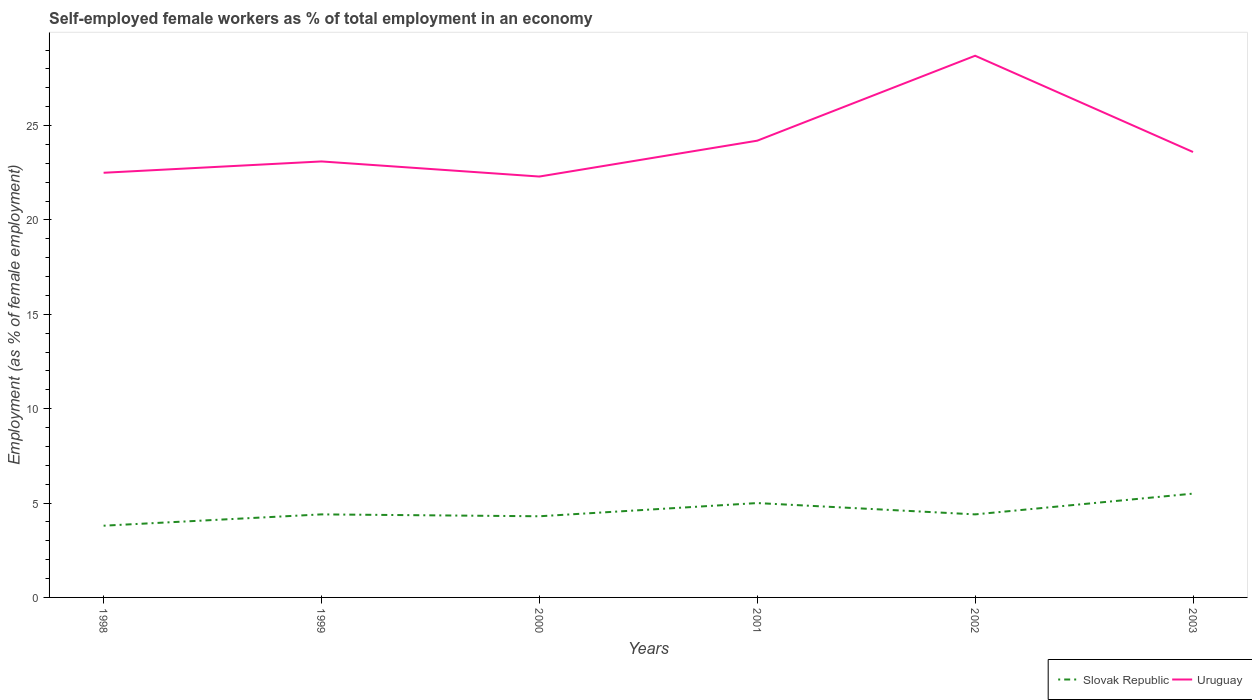How many different coloured lines are there?
Offer a very short reply. 2. Does the line corresponding to Slovak Republic intersect with the line corresponding to Uruguay?
Your answer should be compact. No. Is the number of lines equal to the number of legend labels?
Offer a terse response. Yes. Across all years, what is the maximum percentage of self-employed female workers in Uruguay?
Offer a terse response. 22.3. In which year was the percentage of self-employed female workers in Uruguay maximum?
Offer a very short reply. 2000. What is the total percentage of self-employed female workers in Uruguay in the graph?
Provide a succinct answer. -0.5. What is the difference between the highest and the second highest percentage of self-employed female workers in Uruguay?
Provide a short and direct response. 6.4. What is the difference between the highest and the lowest percentage of self-employed female workers in Slovak Republic?
Make the answer very short. 2. Is the percentage of self-employed female workers in Slovak Republic strictly greater than the percentage of self-employed female workers in Uruguay over the years?
Offer a very short reply. Yes. How many lines are there?
Give a very brief answer. 2. How many years are there in the graph?
Your answer should be compact. 6. What is the difference between two consecutive major ticks on the Y-axis?
Your response must be concise. 5. Are the values on the major ticks of Y-axis written in scientific E-notation?
Make the answer very short. No. Does the graph contain any zero values?
Keep it short and to the point. No. How many legend labels are there?
Your answer should be compact. 2. How are the legend labels stacked?
Your answer should be compact. Horizontal. What is the title of the graph?
Keep it short and to the point. Self-employed female workers as % of total employment in an economy. What is the label or title of the X-axis?
Give a very brief answer. Years. What is the label or title of the Y-axis?
Offer a terse response. Employment (as % of female employment). What is the Employment (as % of female employment) in Slovak Republic in 1998?
Your answer should be compact. 3.8. What is the Employment (as % of female employment) in Uruguay in 1998?
Your answer should be very brief. 22.5. What is the Employment (as % of female employment) of Slovak Republic in 1999?
Your answer should be very brief. 4.4. What is the Employment (as % of female employment) in Uruguay in 1999?
Your answer should be very brief. 23.1. What is the Employment (as % of female employment) of Slovak Republic in 2000?
Provide a short and direct response. 4.3. What is the Employment (as % of female employment) of Uruguay in 2000?
Offer a terse response. 22.3. What is the Employment (as % of female employment) in Uruguay in 2001?
Make the answer very short. 24.2. What is the Employment (as % of female employment) in Slovak Republic in 2002?
Provide a succinct answer. 4.4. What is the Employment (as % of female employment) of Uruguay in 2002?
Offer a very short reply. 28.7. What is the Employment (as % of female employment) in Slovak Republic in 2003?
Give a very brief answer. 5.5. What is the Employment (as % of female employment) in Uruguay in 2003?
Keep it short and to the point. 23.6. Across all years, what is the maximum Employment (as % of female employment) in Uruguay?
Offer a terse response. 28.7. Across all years, what is the minimum Employment (as % of female employment) of Slovak Republic?
Your answer should be very brief. 3.8. Across all years, what is the minimum Employment (as % of female employment) of Uruguay?
Your answer should be compact. 22.3. What is the total Employment (as % of female employment) of Slovak Republic in the graph?
Offer a very short reply. 27.4. What is the total Employment (as % of female employment) of Uruguay in the graph?
Your answer should be very brief. 144.4. What is the difference between the Employment (as % of female employment) in Slovak Republic in 1998 and that in 1999?
Your response must be concise. -0.6. What is the difference between the Employment (as % of female employment) of Uruguay in 1998 and that in 2000?
Keep it short and to the point. 0.2. What is the difference between the Employment (as % of female employment) in Slovak Republic in 1998 and that in 2001?
Your response must be concise. -1.2. What is the difference between the Employment (as % of female employment) in Uruguay in 1998 and that in 2001?
Ensure brevity in your answer.  -1.7. What is the difference between the Employment (as % of female employment) in Slovak Republic in 1998 and that in 2002?
Keep it short and to the point. -0.6. What is the difference between the Employment (as % of female employment) of Slovak Republic in 1999 and that in 2000?
Keep it short and to the point. 0.1. What is the difference between the Employment (as % of female employment) in Uruguay in 1999 and that in 2000?
Your response must be concise. 0.8. What is the difference between the Employment (as % of female employment) in Slovak Republic in 1999 and that in 2001?
Provide a short and direct response. -0.6. What is the difference between the Employment (as % of female employment) of Uruguay in 1999 and that in 2001?
Your answer should be very brief. -1.1. What is the difference between the Employment (as % of female employment) of Uruguay in 2000 and that in 2001?
Offer a terse response. -1.9. What is the difference between the Employment (as % of female employment) of Uruguay in 2000 and that in 2003?
Make the answer very short. -1.3. What is the difference between the Employment (as % of female employment) in Uruguay in 2001 and that in 2002?
Your answer should be compact. -4.5. What is the difference between the Employment (as % of female employment) in Slovak Republic in 2002 and that in 2003?
Make the answer very short. -1.1. What is the difference between the Employment (as % of female employment) in Slovak Republic in 1998 and the Employment (as % of female employment) in Uruguay in 1999?
Provide a short and direct response. -19.3. What is the difference between the Employment (as % of female employment) in Slovak Republic in 1998 and the Employment (as % of female employment) in Uruguay in 2000?
Make the answer very short. -18.5. What is the difference between the Employment (as % of female employment) in Slovak Republic in 1998 and the Employment (as % of female employment) in Uruguay in 2001?
Your response must be concise. -20.4. What is the difference between the Employment (as % of female employment) in Slovak Republic in 1998 and the Employment (as % of female employment) in Uruguay in 2002?
Offer a terse response. -24.9. What is the difference between the Employment (as % of female employment) in Slovak Republic in 1998 and the Employment (as % of female employment) in Uruguay in 2003?
Make the answer very short. -19.8. What is the difference between the Employment (as % of female employment) in Slovak Republic in 1999 and the Employment (as % of female employment) in Uruguay in 2000?
Ensure brevity in your answer.  -17.9. What is the difference between the Employment (as % of female employment) in Slovak Republic in 1999 and the Employment (as % of female employment) in Uruguay in 2001?
Ensure brevity in your answer.  -19.8. What is the difference between the Employment (as % of female employment) in Slovak Republic in 1999 and the Employment (as % of female employment) in Uruguay in 2002?
Your answer should be very brief. -24.3. What is the difference between the Employment (as % of female employment) in Slovak Republic in 1999 and the Employment (as % of female employment) in Uruguay in 2003?
Give a very brief answer. -19.2. What is the difference between the Employment (as % of female employment) in Slovak Republic in 2000 and the Employment (as % of female employment) in Uruguay in 2001?
Give a very brief answer. -19.9. What is the difference between the Employment (as % of female employment) in Slovak Republic in 2000 and the Employment (as % of female employment) in Uruguay in 2002?
Give a very brief answer. -24.4. What is the difference between the Employment (as % of female employment) in Slovak Republic in 2000 and the Employment (as % of female employment) in Uruguay in 2003?
Ensure brevity in your answer.  -19.3. What is the difference between the Employment (as % of female employment) in Slovak Republic in 2001 and the Employment (as % of female employment) in Uruguay in 2002?
Your answer should be compact. -23.7. What is the difference between the Employment (as % of female employment) in Slovak Republic in 2001 and the Employment (as % of female employment) in Uruguay in 2003?
Your answer should be very brief. -18.6. What is the difference between the Employment (as % of female employment) of Slovak Republic in 2002 and the Employment (as % of female employment) of Uruguay in 2003?
Offer a terse response. -19.2. What is the average Employment (as % of female employment) in Slovak Republic per year?
Your response must be concise. 4.57. What is the average Employment (as % of female employment) in Uruguay per year?
Your answer should be very brief. 24.07. In the year 1998, what is the difference between the Employment (as % of female employment) in Slovak Republic and Employment (as % of female employment) in Uruguay?
Keep it short and to the point. -18.7. In the year 1999, what is the difference between the Employment (as % of female employment) of Slovak Republic and Employment (as % of female employment) of Uruguay?
Your answer should be compact. -18.7. In the year 2001, what is the difference between the Employment (as % of female employment) in Slovak Republic and Employment (as % of female employment) in Uruguay?
Offer a terse response. -19.2. In the year 2002, what is the difference between the Employment (as % of female employment) of Slovak Republic and Employment (as % of female employment) of Uruguay?
Provide a short and direct response. -24.3. In the year 2003, what is the difference between the Employment (as % of female employment) in Slovak Republic and Employment (as % of female employment) in Uruguay?
Your answer should be compact. -18.1. What is the ratio of the Employment (as % of female employment) of Slovak Republic in 1998 to that in 1999?
Your response must be concise. 0.86. What is the ratio of the Employment (as % of female employment) in Slovak Republic in 1998 to that in 2000?
Ensure brevity in your answer.  0.88. What is the ratio of the Employment (as % of female employment) of Slovak Republic in 1998 to that in 2001?
Your answer should be very brief. 0.76. What is the ratio of the Employment (as % of female employment) in Uruguay in 1998 to that in 2001?
Keep it short and to the point. 0.93. What is the ratio of the Employment (as % of female employment) in Slovak Republic in 1998 to that in 2002?
Offer a terse response. 0.86. What is the ratio of the Employment (as % of female employment) in Uruguay in 1998 to that in 2002?
Provide a succinct answer. 0.78. What is the ratio of the Employment (as % of female employment) of Slovak Republic in 1998 to that in 2003?
Ensure brevity in your answer.  0.69. What is the ratio of the Employment (as % of female employment) of Uruguay in 1998 to that in 2003?
Make the answer very short. 0.95. What is the ratio of the Employment (as % of female employment) of Slovak Republic in 1999 to that in 2000?
Give a very brief answer. 1.02. What is the ratio of the Employment (as % of female employment) in Uruguay in 1999 to that in 2000?
Your answer should be compact. 1.04. What is the ratio of the Employment (as % of female employment) of Slovak Republic in 1999 to that in 2001?
Give a very brief answer. 0.88. What is the ratio of the Employment (as % of female employment) of Uruguay in 1999 to that in 2001?
Your response must be concise. 0.95. What is the ratio of the Employment (as % of female employment) of Slovak Republic in 1999 to that in 2002?
Offer a very short reply. 1. What is the ratio of the Employment (as % of female employment) in Uruguay in 1999 to that in 2002?
Provide a succinct answer. 0.8. What is the ratio of the Employment (as % of female employment) of Slovak Republic in 1999 to that in 2003?
Make the answer very short. 0.8. What is the ratio of the Employment (as % of female employment) in Uruguay in 1999 to that in 2003?
Provide a succinct answer. 0.98. What is the ratio of the Employment (as % of female employment) in Slovak Republic in 2000 to that in 2001?
Offer a very short reply. 0.86. What is the ratio of the Employment (as % of female employment) in Uruguay in 2000 to that in 2001?
Ensure brevity in your answer.  0.92. What is the ratio of the Employment (as % of female employment) of Slovak Republic in 2000 to that in 2002?
Your response must be concise. 0.98. What is the ratio of the Employment (as % of female employment) in Uruguay in 2000 to that in 2002?
Your answer should be compact. 0.78. What is the ratio of the Employment (as % of female employment) in Slovak Republic in 2000 to that in 2003?
Give a very brief answer. 0.78. What is the ratio of the Employment (as % of female employment) in Uruguay in 2000 to that in 2003?
Ensure brevity in your answer.  0.94. What is the ratio of the Employment (as % of female employment) in Slovak Republic in 2001 to that in 2002?
Provide a succinct answer. 1.14. What is the ratio of the Employment (as % of female employment) in Uruguay in 2001 to that in 2002?
Give a very brief answer. 0.84. What is the ratio of the Employment (as % of female employment) in Slovak Republic in 2001 to that in 2003?
Your response must be concise. 0.91. What is the ratio of the Employment (as % of female employment) of Uruguay in 2001 to that in 2003?
Your answer should be very brief. 1.03. What is the ratio of the Employment (as % of female employment) in Slovak Republic in 2002 to that in 2003?
Provide a succinct answer. 0.8. What is the ratio of the Employment (as % of female employment) in Uruguay in 2002 to that in 2003?
Offer a very short reply. 1.22. What is the difference between the highest and the lowest Employment (as % of female employment) of Slovak Republic?
Ensure brevity in your answer.  1.7. 